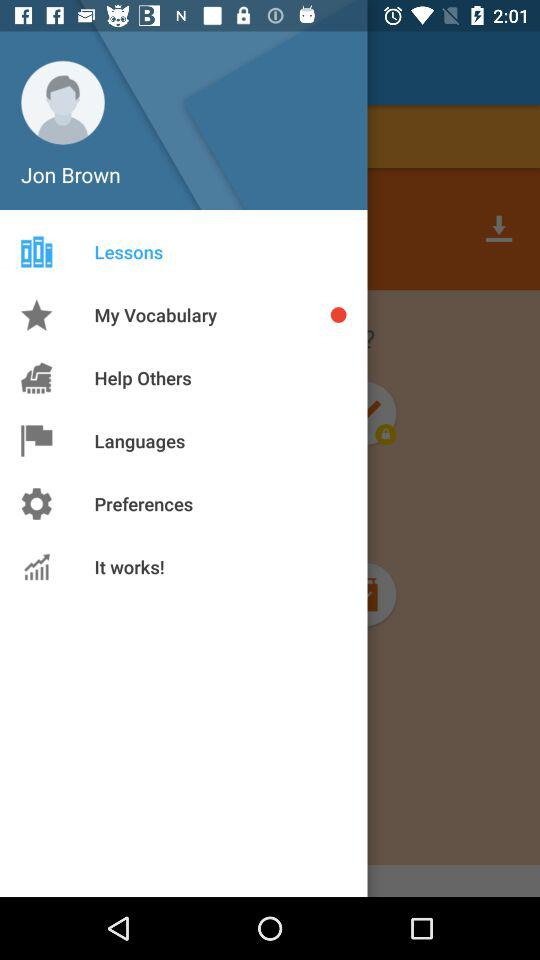How many items have a red circle next to them?
Answer the question using a single word or phrase. 1 